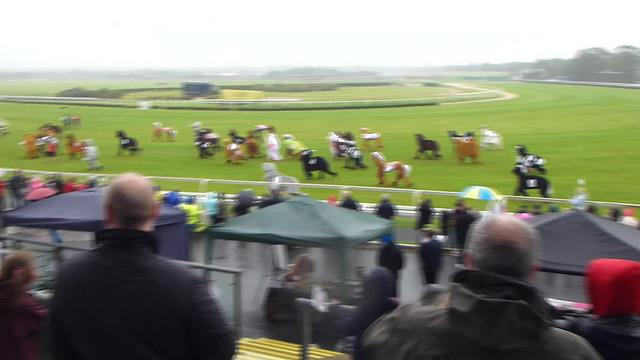How many awnings are there?

Choices:
A) eight
B) three
C) none
D) four three 